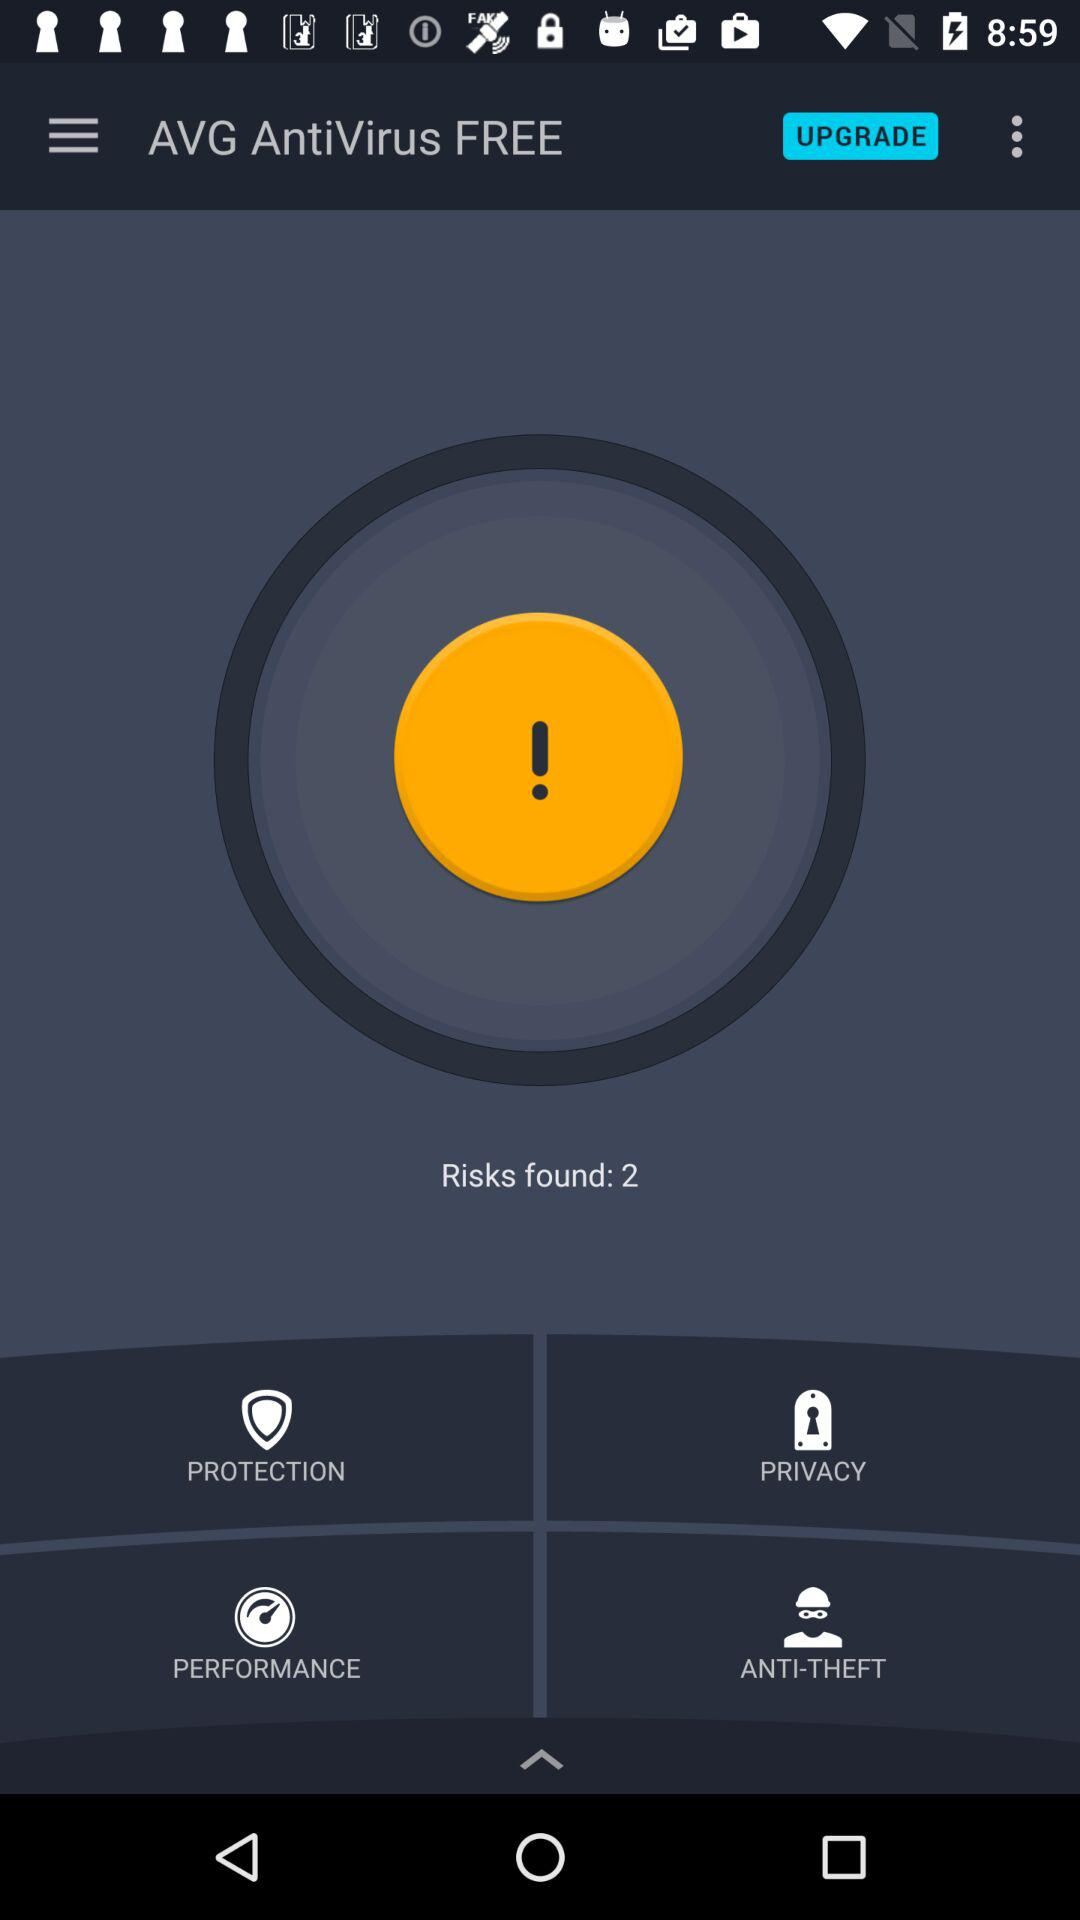How many risks are there?
Answer the question using a single word or phrase. 2 